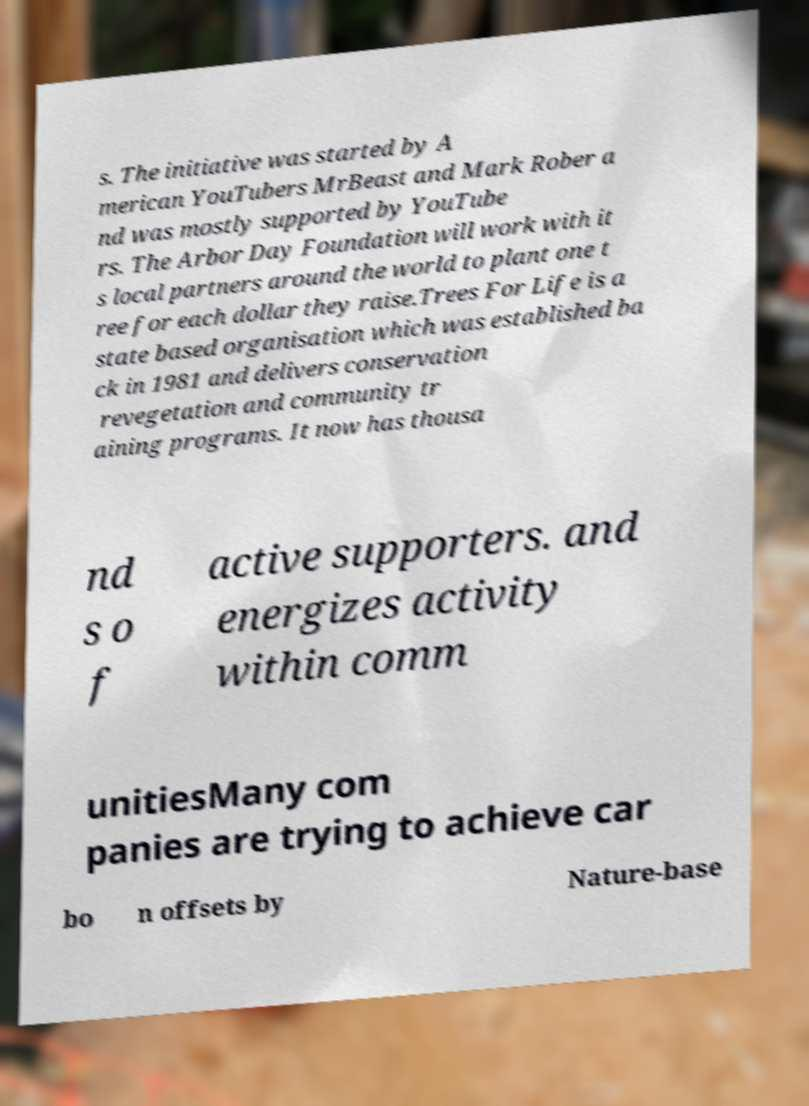Could you assist in decoding the text presented in this image and type it out clearly? s. The initiative was started by A merican YouTubers MrBeast and Mark Rober a nd was mostly supported by YouTube rs. The Arbor Day Foundation will work with it s local partners around the world to plant one t ree for each dollar they raise.Trees For Life is a state based organisation which was established ba ck in 1981 and delivers conservation revegetation and community tr aining programs. It now has thousa nd s o f active supporters. and energizes activity within comm unitiesMany com panies are trying to achieve car bo n offsets by Nature-base 